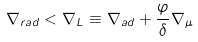Convert formula to latex. <formula><loc_0><loc_0><loc_500><loc_500>\nabla _ { r a d } < \nabla _ { L } \equiv \nabla _ { a d } + \frac { \varphi } { \delta } \nabla _ { \mu }</formula> 